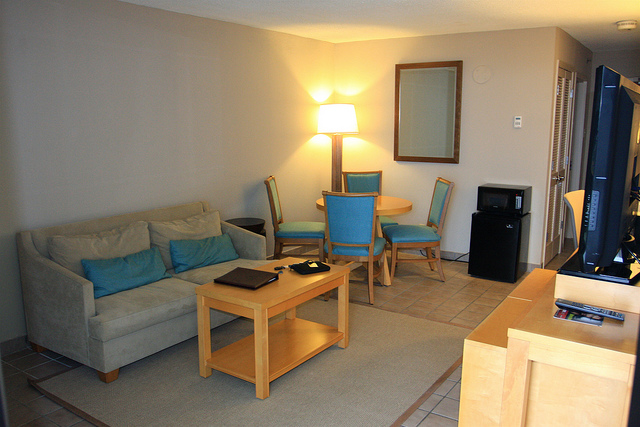<image>What type of ceiling is this? It is ambiguous what type of ceiling it is. It could be a flat, painted, drop ceiling, plaster, stucco, or white. What type of ceiling is this? It is not sure what type of ceiling is in the image. It can be seen as flat, drop ceiling, plaster, stucco, or painted. 